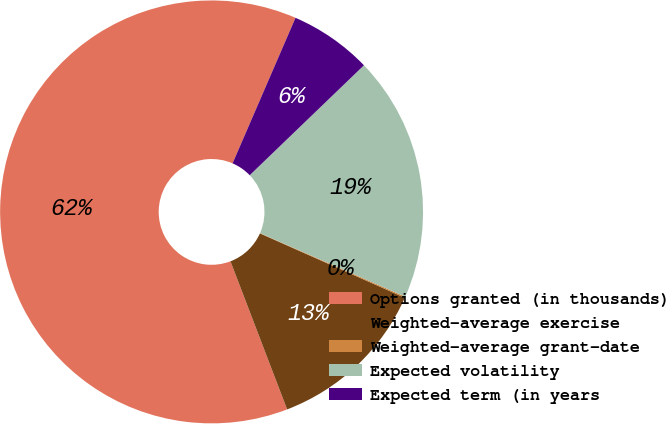<chart> <loc_0><loc_0><loc_500><loc_500><pie_chart><fcel>Options granted (in thousands)<fcel>Weighted-average exercise<fcel>Weighted-average grant-date<fcel>Expected volatility<fcel>Expected term (in years<nl><fcel>62.31%<fcel>12.53%<fcel>0.09%<fcel>18.76%<fcel>6.31%<nl></chart> 